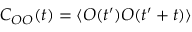<formula> <loc_0><loc_0><loc_500><loc_500>C _ { O O } ( t ) = \langle O ( t ^ { \prime } ) O ( t ^ { \prime } + t ) \rangle</formula> 